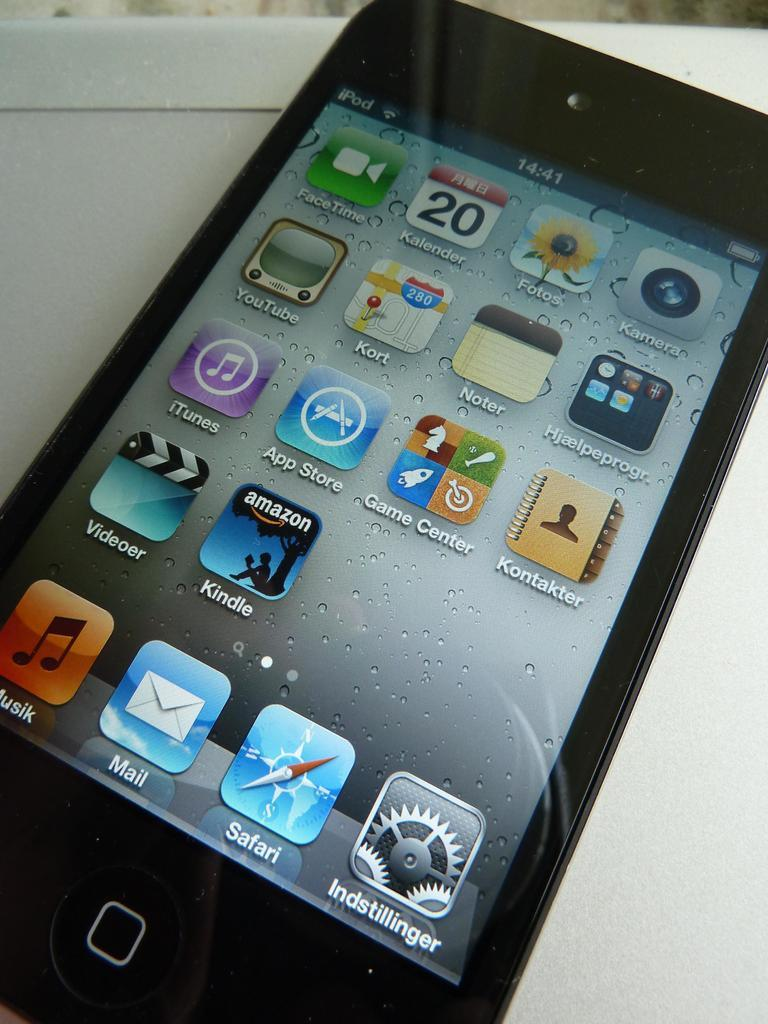Provide a one-sentence caption for the provided image. An iphone that is unlocked with a safari app on the bottom. 